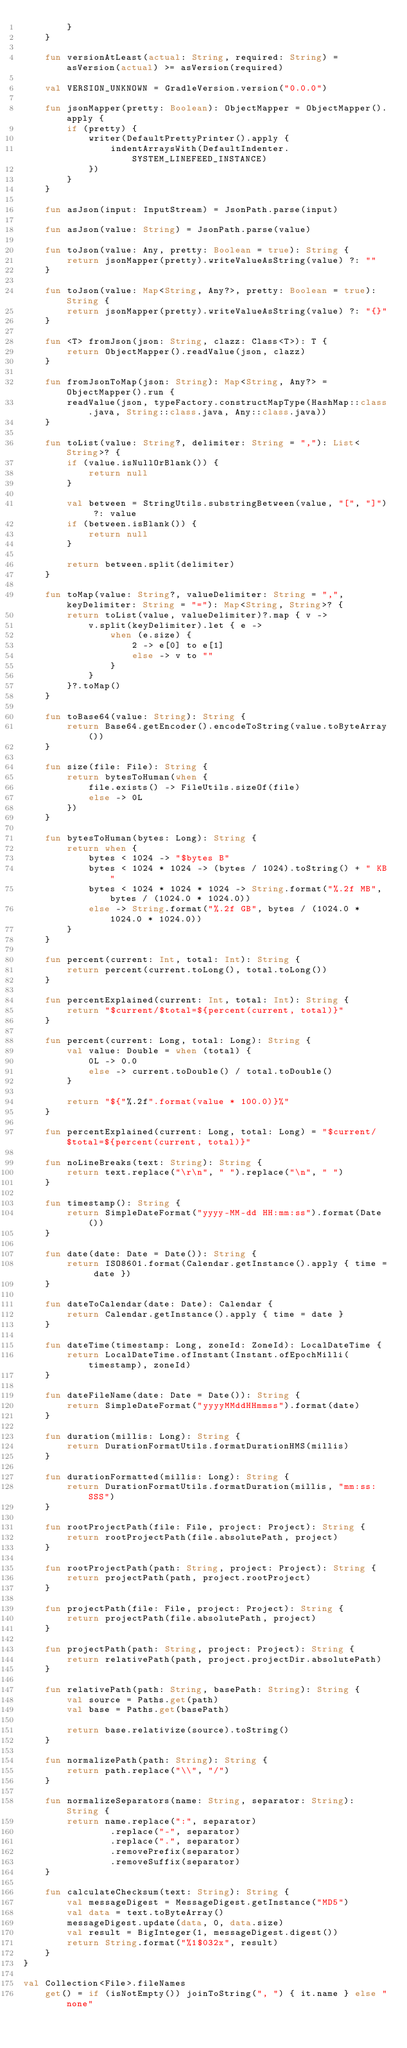<code> <loc_0><loc_0><loc_500><loc_500><_Kotlin_>        }
    }

    fun versionAtLeast(actual: String, required: String) = asVersion(actual) >= asVersion(required)

    val VERSION_UNKNOWN = GradleVersion.version("0.0.0")

    fun jsonMapper(pretty: Boolean): ObjectMapper = ObjectMapper().apply {
        if (pretty) {
            writer(DefaultPrettyPrinter().apply {
                indentArraysWith(DefaultIndenter.SYSTEM_LINEFEED_INSTANCE)
            })
        }
    }

    fun asJson(input: InputStream) = JsonPath.parse(input)

    fun asJson(value: String) = JsonPath.parse(value)

    fun toJson(value: Any, pretty: Boolean = true): String {
        return jsonMapper(pretty).writeValueAsString(value) ?: ""
    }

    fun toJson(value: Map<String, Any?>, pretty: Boolean = true): String {
        return jsonMapper(pretty).writeValueAsString(value) ?: "{}"
    }

    fun <T> fromJson(json: String, clazz: Class<T>): T {
        return ObjectMapper().readValue(json, clazz)
    }

    fun fromJsonToMap(json: String): Map<String, Any?> = ObjectMapper().run {
        readValue(json, typeFactory.constructMapType(HashMap::class.java, String::class.java, Any::class.java))
    }

    fun toList(value: String?, delimiter: String = ","): List<String>? {
        if (value.isNullOrBlank()) {
            return null
        }

        val between = StringUtils.substringBetween(value, "[", "]") ?: value
        if (between.isBlank()) {
            return null
        }

        return between.split(delimiter)
    }

    fun toMap(value: String?, valueDelimiter: String = ",", keyDelimiter: String = "="): Map<String, String>? {
        return toList(value, valueDelimiter)?.map { v ->
            v.split(keyDelimiter).let { e ->
                when (e.size) {
                    2 -> e[0] to e[1]
                    else -> v to ""
                }
            }
        }?.toMap()
    }

    fun toBase64(value: String): String {
        return Base64.getEncoder().encodeToString(value.toByteArray())
    }

    fun size(file: File): String {
        return bytesToHuman(when {
            file.exists() -> FileUtils.sizeOf(file)
            else -> 0L
        })
    }

    fun bytesToHuman(bytes: Long): String {
        return when {
            bytes < 1024 -> "$bytes B"
            bytes < 1024 * 1024 -> (bytes / 1024).toString() + " KB"
            bytes < 1024 * 1024 * 1024 -> String.format("%.2f MB", bytes / (1024.0 * 1024.0))
            else -> String.format("%.2f GB", bytes / (1024.0 * 1024.0 * 1024.0))
        }
    }

    fun percent(current: Int, total: Int): String {
        return percent(current.toLong(), total.toLong())
    }

    fun percentExplained(current: Int, total: Int): String {
        return "$current/$total=${percent(current, total)}"
    }

    fun percent(current: Long, total: Long): String {
        val value: Double = when (total) {
            0L -> 0.0
            else -> current.toDouble() / total.toDouble()
        }

        return "${"%.2f".format(value * 100.0)}%"
    }

    fun percentExplained(current: Long, total: Long) = "$current/$total=${percent(current, total)}"

    fun noLineBreaks(text: String): String {
        return text.replace("\r\n", " ").replace("\n", " ")
    }

    fun timestamp(): String {
        return SimpleDateFormat("yyyy-MM-dd HH:mm:ss").format(Date())
    }

    fun date(date: Date = Date()): String {
        return ISO8601.format(Calendar.getInstance().apply { time = date })
    }

    fun dateToCalendar(date: Date): Calendar {
        return Calendar.getInstance().apply { time = date }
    }

    fun dateTime(timestamp: Long, zoneId: ZoneId): LocalDateTime {
        return LocalDateTime.ofInstant(Instant.ofEpochMilli(timestamp), zoneId)
    }

    fun dateFileName(date: Date = Date()): String {
        return SimpleDateFormat("yyyyMMddHHmmss").format(date)
    }

    fun duration(millis: Long): String {
        return DurationFormatUtils.formatDurationHMS(millis)
    }

    fun durationFormatted(millis: Long): String {
        return DurationFormatUtils.formatDuration(millis, "mm:ss:SSS")
    }

    fun rootProjectPath(file: File, project: Project): String {
        return rootProjectPath(file.absolutePath, project)
    }

    fun rootProjectPath(path: String, project: Project): String {
        return projectPath(path, project.rootProject)
    }

    fun projectPath(file: File, project: Project): String {
        return projectPath(file.absolutePath, project)
    }

    fun projectPath(path: String, project: Project): String {
        return relativePath(path, project.projectDir.absolutePath)
    }

    fun relativePath(path: String, basePath: String): String {
        val source = Paths.get(path)
        val base = Paths.get(basePath)

        return base.relativize(source).toString()
    }

    fun normalizePath(path: String): String {
        return path.replace("\\", "/")
    }

    fun normalizeSeparators(name: String, separator: String): String {
        return name.replace(":", separator)
                .replace("-", separator)
                .replace(".", separator)
                .removePrefix(separator)
                .removeSuffix(separator)
    }

    fun calculateChecksum(text: String): String {
        val messageDigest = MessageDigest.getInstance("MD5")
        val data = text.toByteArray()
        messageDigest.update(data, 0, data.size)
        val result = BigInteger(1, messageDigest.digest())
        return String.format("%1$032x", result)
    }
}

val Collection<File>.fileNames
    get() = if (isNotEmpty()) joinToString(", ") { it.name } else "none"</code> 